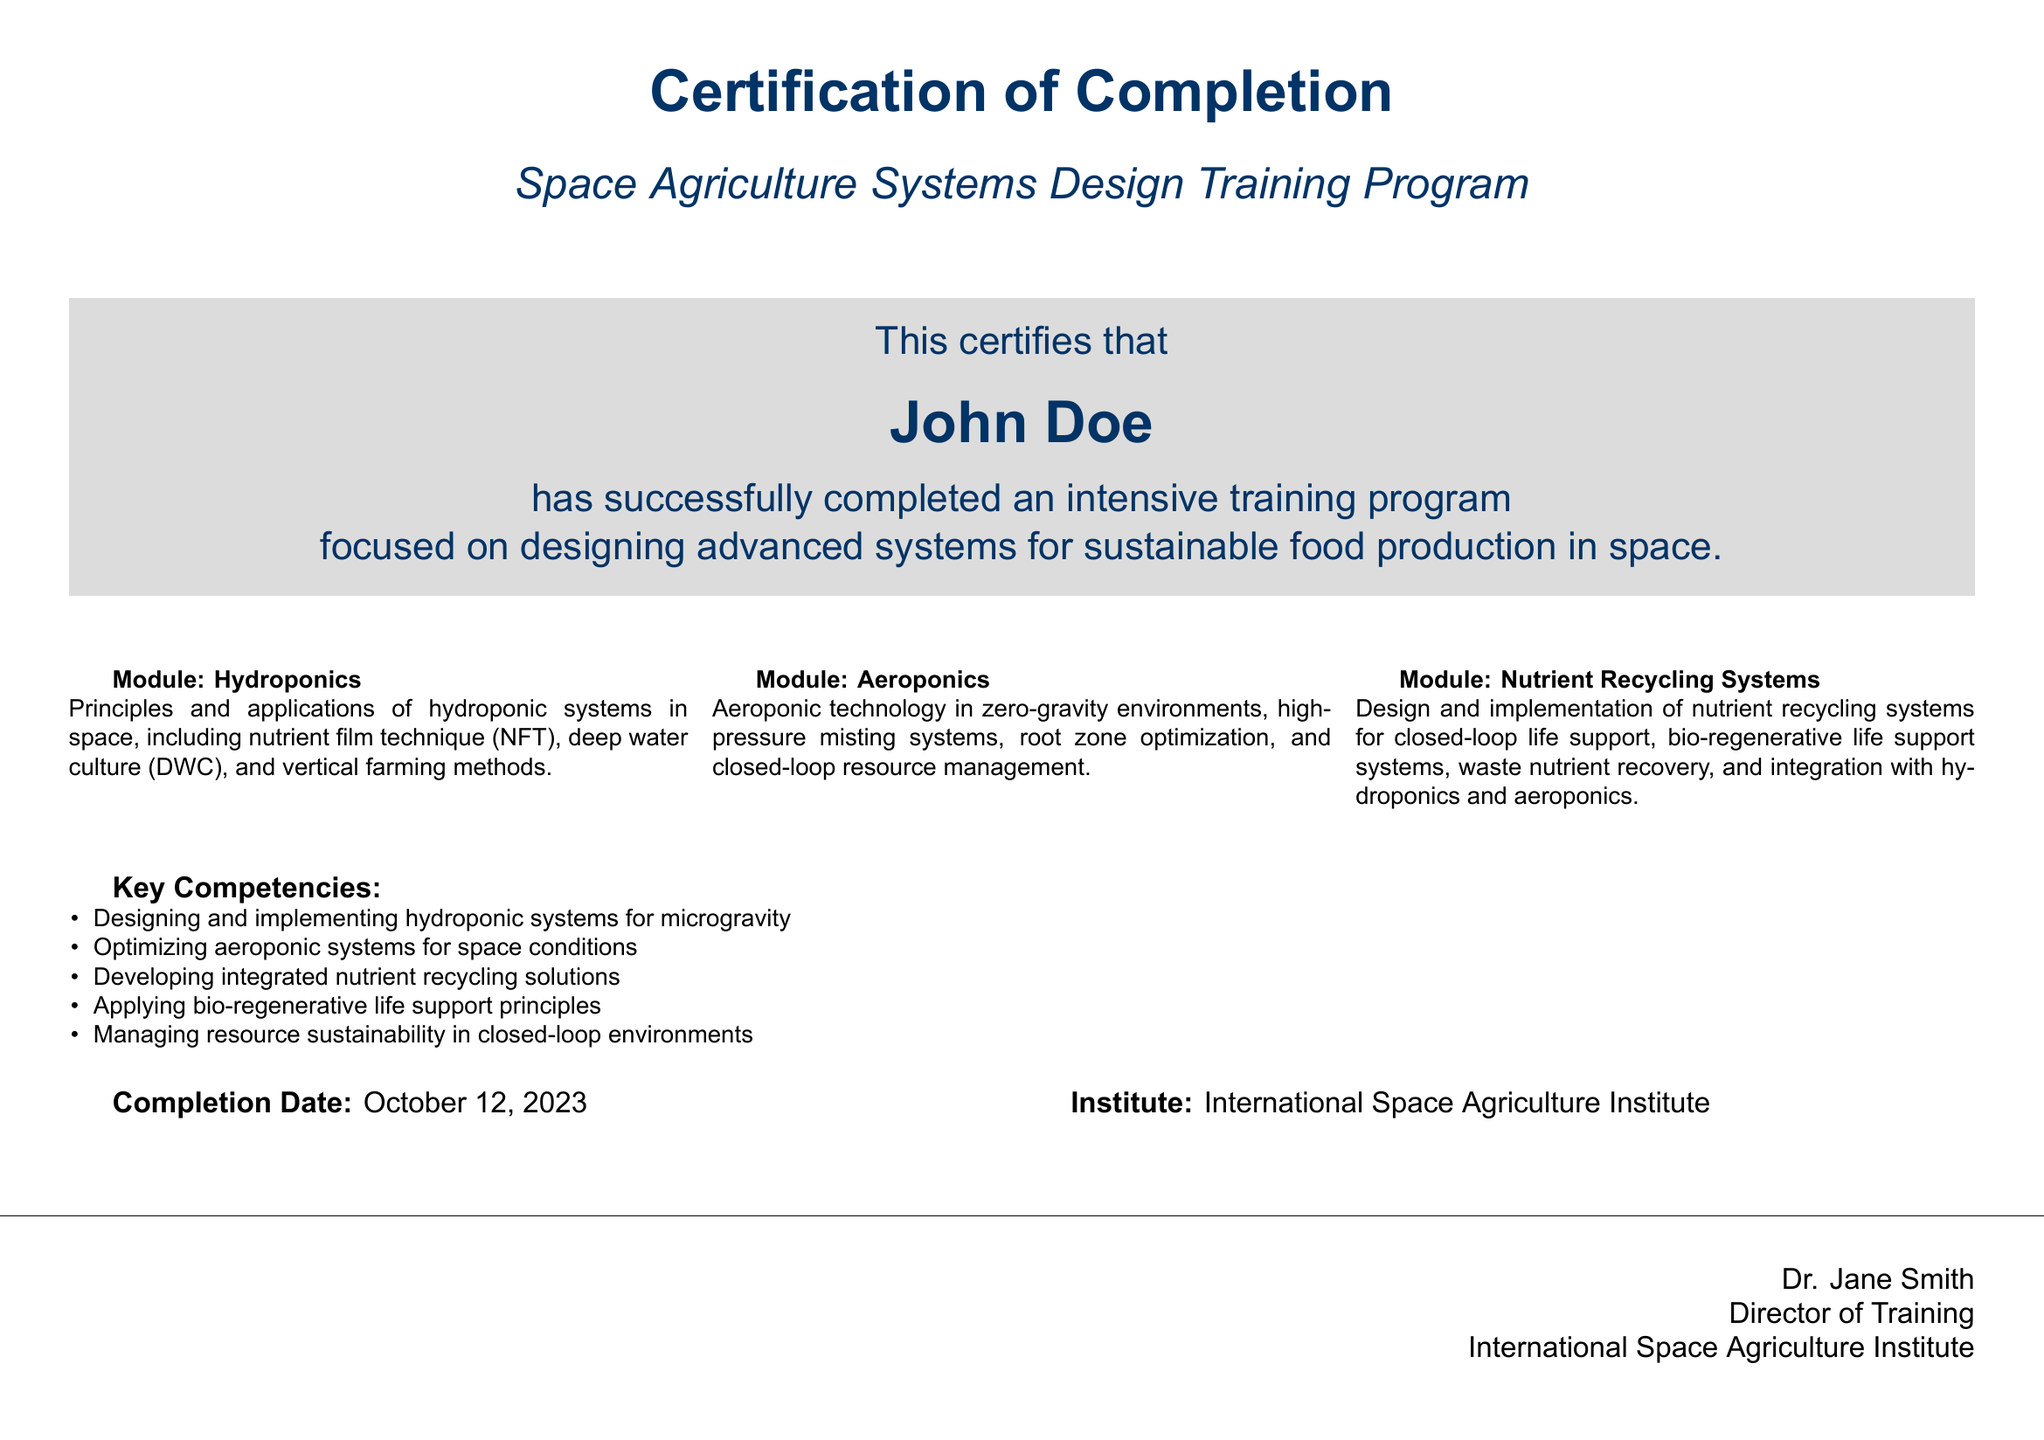What is the name of the program? The program is titled "Space Agriculture Systems Design Training Program."
Answer: Space Agriculture Systems Design Training Program Who is the certificate issued to? The certificate is issued to the individual named in the document, which states their name clearly.
Answer: John Doe What is the completion date of the training program? The completion date is stated in the document, indicating when the training was completed.
Answer: October 12, 2023 Which institute conducted the training? The document specifies the institute responsible for the training program.
Answer: International Space Agriculture Institute What are the key competencies related to aeroponics? Key competencies include several advanced skills specifically related to aeroponic systems, mentioned in the document.
Answer: Optimizing aeroponic systems for space conditions What is a module covered in the training program? The document lists several modules, one of which is highlighted under the module section.
Answer: Hydroponics How many modules are listed in the document? The document clearly outlines the number of modules provided in the training program.
Answer: Three Who is the director of training? The document lists the name and title of the person signing the certificate.
Answer: Dr. Jane Smith What type of learning does the program focus on? The focus of the program is indicated in the introductory lines of the certificate.
Answer: Sustainable food production in space 